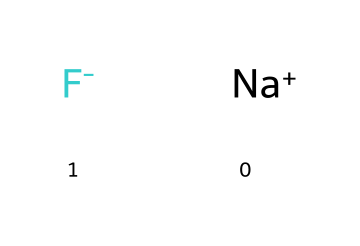What ions are present in this chemical? The chemical structure indicates two distinct ions: sodium ion (Na+) and fluoride ion (F-). The 'Na+' represents the sodium ion, and the 'F-' represents the fluoride ion.
Answer: sodium and fluoride How many atoms are in the chemical composition? The structure contains two atoms in total: one sodium atom and one fluorine atom. The sodium ion and fluoride ion together sum up to two individual atoms.
Answer: two What is the charge of the fluoride ion? The structure shows that the fluoride ion is represented as 'F-', which indicates it carries a negative charge. Therefore, the charge of the fluoride ion is negative one.
Answer: negative Which ion acts as a base in this chemical? In the context of the chemical structure provided, sodium ion (Na+) acts as a base. Bases are often cations, which are positively charged ions.
Answer: sodium Why does fluoride prevent tooth decay? Fluoride ions (F-) are known to strengthen tooth enamel and make it more resistant to acid attacks from bacteria, which helps prevent tooth decay. The presence of fluoride in dental products is essential for this protective effect.
Answer: strengthens enamel What type of chemical is fluoride classified as? Fluoride is classified as a halide ion because it is derived from a halogen (fluorine) and exists in ionic form. Halides are typically the ions of halogens and have unique properties.
Answer: halide Is sodium fluoride considered a salt? Yes, sodium fluoride (NaF) is considered a salt because it is formed from the neutralization of a strong acid (hydrofluoric acid) and a strong base (sodium hydroxide), resulting in an ionic compound.
Answer: salt 